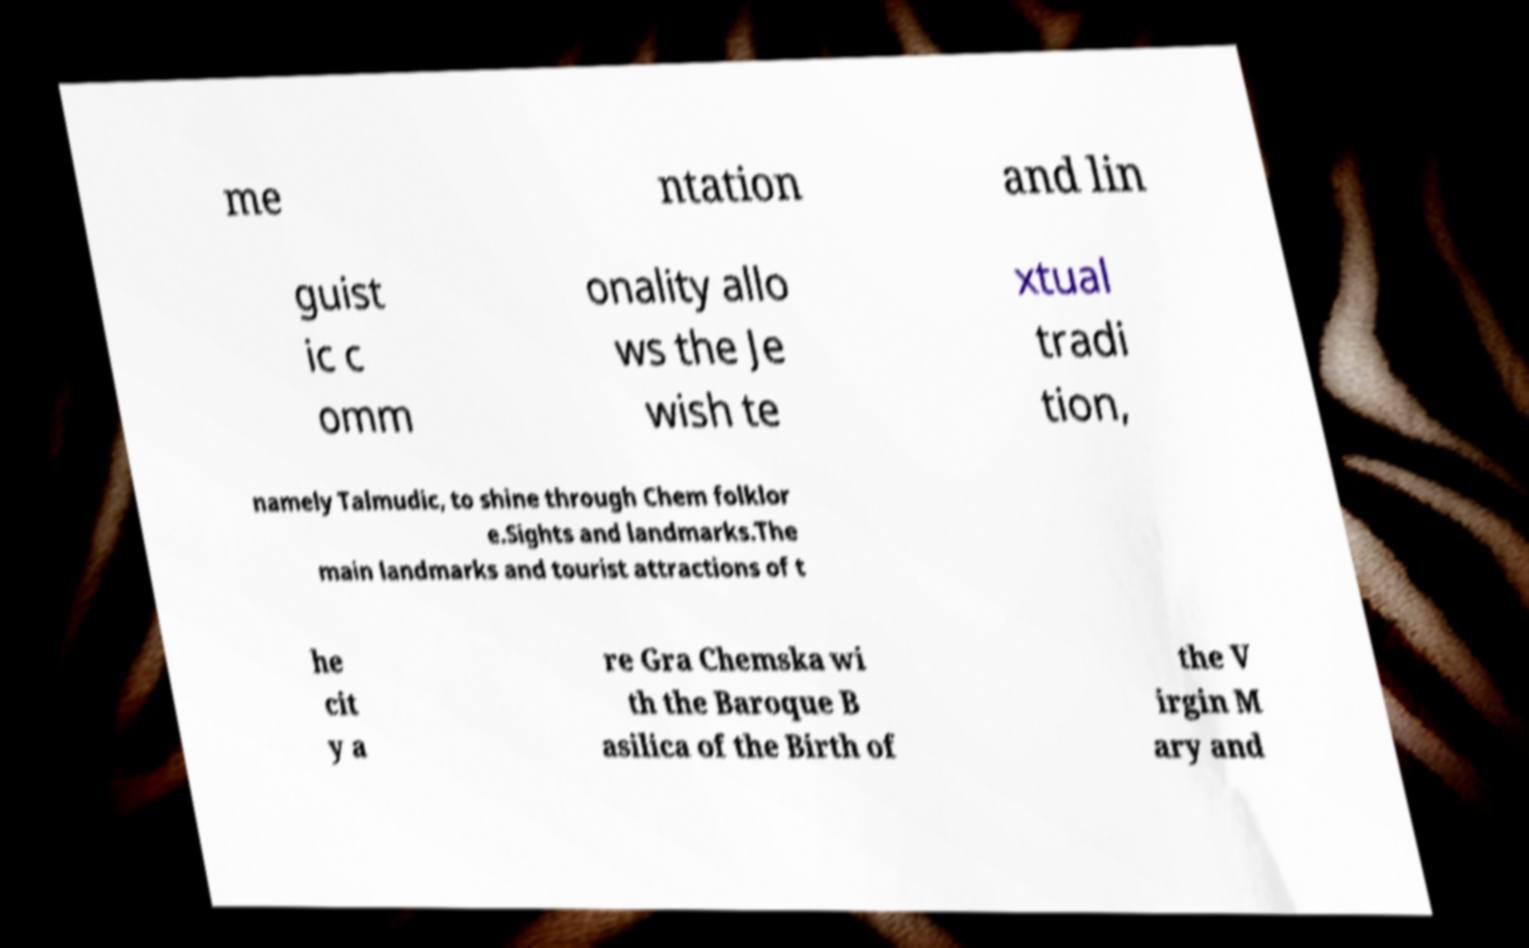Could you assist in decoding the text presented in this image and type it out clearly? me ntation and lin guist ic c omm onality allo ws the Je wish te xtual tradi tion, namely Talmudic, to shine through Chem folklor e.Sights and landmarks.The main landmarks and tourist attractions of t he cit y a re Gra Chemska wi th the Baroque B asilica of the Birth of the V irgin M ary and 